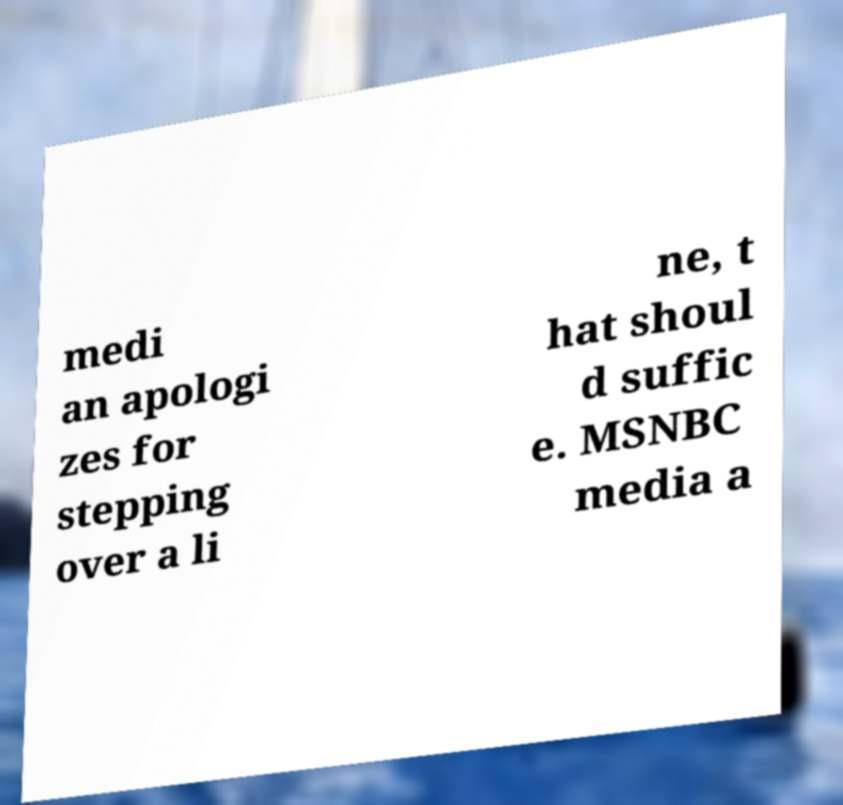What messages or text are displayed in this image? I need them in a readable, typed format. medi an apologi zes for stepping over a li ne, t hat shoul d suffic e. MSNBC media a 